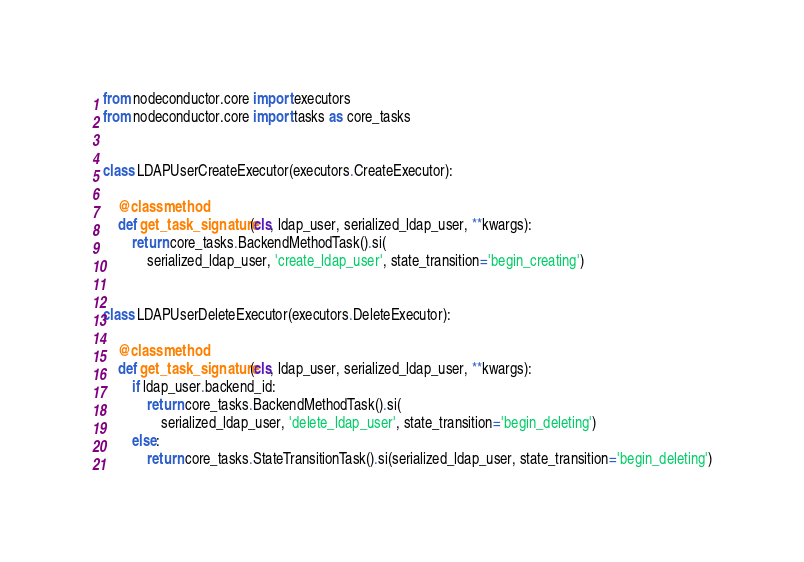<code> <loc_0><loc_0><loc_500><loc_500><_Python_>from nodeconductor.core import executors
from nodeconductor.core import tasks as core_tasks


class LDAPUserCreateExecutor(executors.CreateExecutor):

    @classmethod
    def get_task_signature(cls, ldap_user, serialized_ldap_user, **kwargs):
        return core_tasks.BackendMethodTask().si(
            serialized_ldap_user, 'create_ldap_user', state_transition='begin_creating')


class LDAPUserDeleteExecutor(executors.DeleteExecutor):

    @classmethod
    def get_task_signature(cls, ldap_user, serialized_ldap_user, **kwargs):
        if ldap_user.backend_id:
            return core_tasks.BackendMethodTask().si(
                serialized_ldap_user, 'delete_ldap_user', state_transition='begin_deleting')
        else:
            return core_tasks.StateTransitionTask().si(serialized_ldap_user, state_transition='begin_deleting')
</code> 